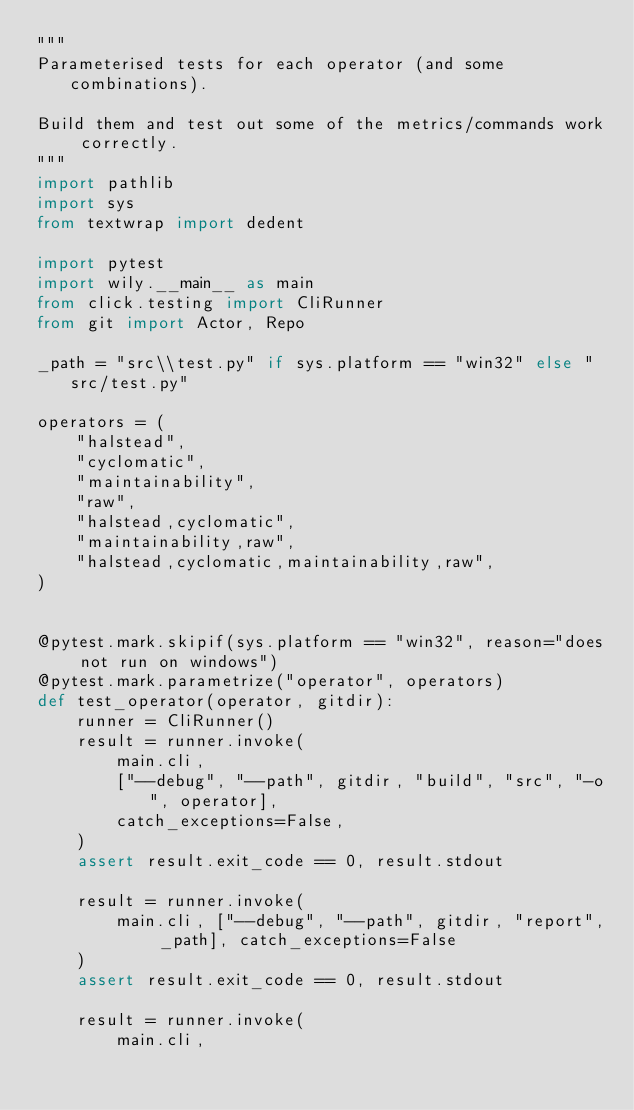<code> <loc_0><loc_0><loc_500><loc_500><_Python_>"""
Parameterised tests for each operator (and some combinations).

Build them and test out some of the metrics/commands work correctly.
"""
import pathlib
import sys
from textwrap import dedent

import pytest
import wily.__main__ as main
from click.testing import CliRunner
from git import Actor, Repo

_path = "src\\test.py" if sys.platform == "win32" else "src/test.py"

operators = (
    "halstead",
    "cyclomatic",
    "maintainability",
    "raw",
    "halstead,cyclomatic",
    "maintainability,raw",
    "halstead,cyclomatic,maintainability,raw",
)


@pytest.mark.skipif(sys.platform == "win32", reason="does not run on windows")
@pytest.mark.parametrize("operator", operators)
def test_operator(operator, gitdir):
    runner = CliRunner()
    result = runner.invoke(
        main.cli,
        ["--debug", "--path", gitdir, "build", "src", "-o", operator],
        catch_exceptions=False,
    )
    assert result.exit_code == 0, result.stdout

    result = runner.invoke(
        main.cli, ["--debug", "--path", gitdir, "report", _path], catch_exceptions=False
    )
    assert result.exit_code == 0, result.stdout

    result = runner.invoke(
        main.cli,</code> 